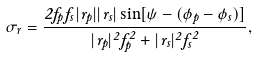Convert formula to latex. <formula><loc_0><loc_0><loc_500><loc_500>\sigma _ { r } = \frac { 2 f _ { p } f _ { s } | r _ { p } | | r _ { s } | \sin [ \psi - ( \phi _ { p } - \phi _ { s } ) ] } { | r _ { p } | ^ { 2 } f _ { p } ^ { 2 } + | r _ { s } | ^ { 2 } f _ { s } ^ { 2 } } ,</formula> 